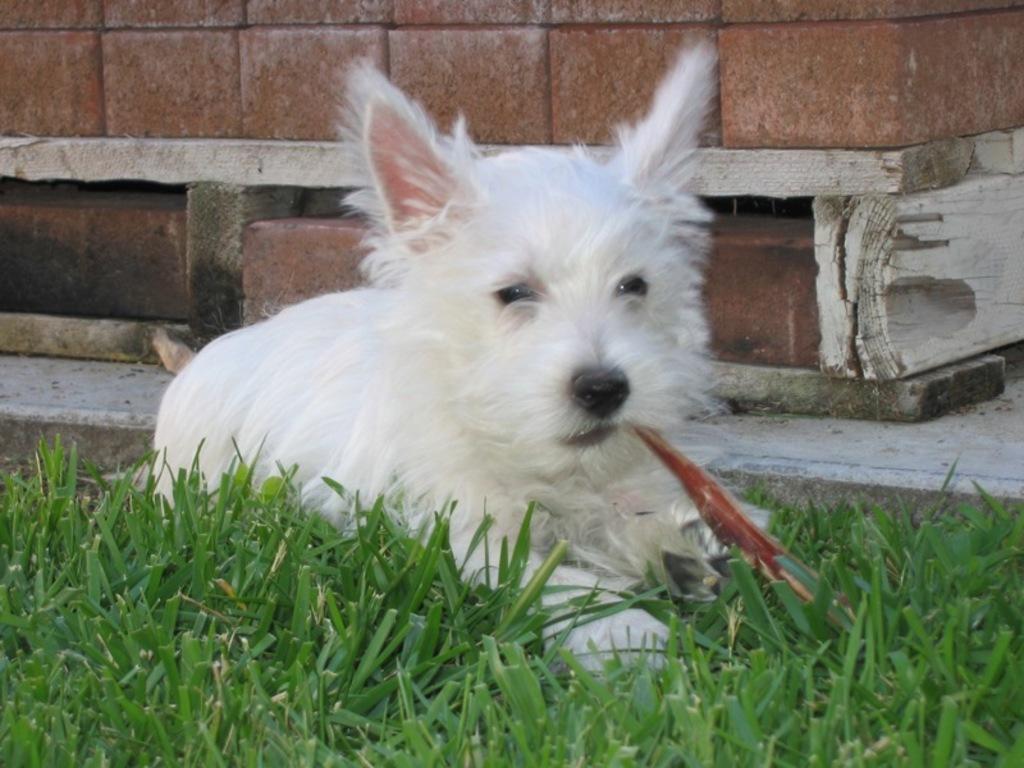In one or two sentences, can you explain what this image depicts? In this picture there is a dog holding an object with mouth and we can see grass. In the background of the image we can see wall. 